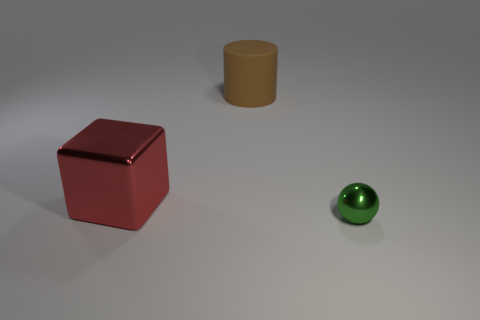Add 1 brown rubber cylinders. How many objects exist? 4 Subtract all cylinders. How many objects are left? 2 Add 1 small things. How many small things exist? 2 Subtract 0 green cubes. How many objects are left? 3 Subtract all small shiny balls. Subtract all small balls. How many objects are left? 1 Add 3 green balls. How many green balls are left? 4 